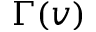Convert formula to latex. <formula><loc_0><loc_0><loc_500><loc_500>\Gamma ( v )</formula> 